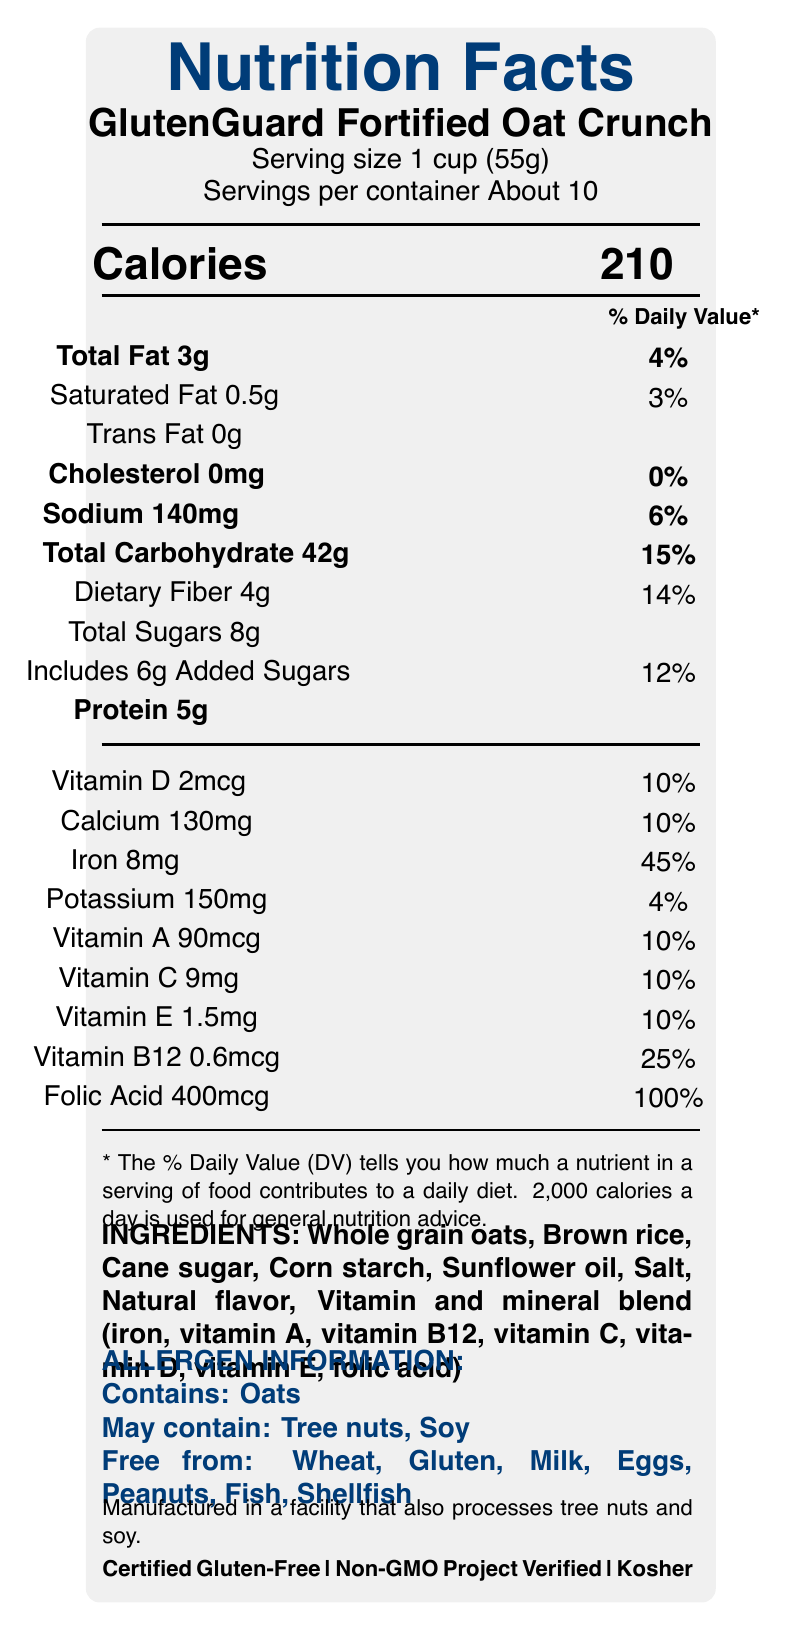what is the serving size for GlutenGuard Fortified Oat Crunch? The serving size is explicitly stated in the Nutrition Facts label as "Serving size 1 cup (55g)".
Answer: 1 cup (55g) how many servings are in each container? The label mentions "Servings per container About 10".
Answer: About 10 how much iron is in one serving? The Nutrition Facts label states that there is 8mg of iron per serving.
Answer: 8mg what percentage of the daily value of dietary fiber does one serving provide? The document indicates that one serving provides 14% of the daily value for dietary fiber.
Answer: 14% list the vitamins that are fortified in this cereal. The ingredients list these vitamins and minerals as part of a "Vitamin and mineral blend".
Answer: Vitamin A, Vitamin B12, Vitamin C, Vitamin D, Vitamin E, folic acid which allergens does this product contain? A. Tree nuts B. Soy C. Oats D. Milk The label states that the cereal contains "Oats".
Answer: C. Oats how many grams of total sugars are in one serving? The Nutrition Facts label shows that there are 8 grams of total sugars per serving.
Answer: 8g what is the total carbohydrate content per serving? A. 14g B. 30g C. 42g D. 50g The document indicates a total carbohydrate content of 42 grams per serving.
Answer: C. 42g is this cereal gluten-free? The label states that the cereal is "Certified Gluten-Free".
Answer: Yes what is the main idea of this Nutrition Facts label? The document provides detailed information about a gluten-free cereal, including its serving size, nutritional content per serving, vitamins and minerals, ingredients, potential allergens, and certifications.
Answer: The label describes the nutritional content, ingredients, allergens, and certifications of GlutenGuard Fortified Oat Crunch, a gluten-free cereal. what kind of packaging does this product have? There is no visible information in the document about the type of packaging used for this product.
Answer: Cannot be determined which vitamin is present in the highest percentage of daily value? The label shows folic acid as having a daily value of 100%.
Answer: Folic acid how much sodium is in one serving? The label indicates that there are 140mg of sodium per serving.
Answer: 140mg name two certifications that this cereal has. The certification section lists "Certified Gluten-Free" and "Non-GMO Project Verified" among others.
Answer: Certified Gluten-Free, Non-GMO Project Verified is the font size used for the product name larger than the font size used for the serving size? The product name is displayed using a larger font size than the serving size.
Answer: Yes how is allergen control managed in the manufacturing process? The label mentions "strict allergen control protocols in place to minimize cross-contamination risks".
Answer: The label states that strict allergen control protocols are in place to minimize cross-contamination risks. what is the caloric value of one serving? A. 100 calories B. 150 calories C. 200 calories D. 210 calories The document lists the caloric value for one serving as 210 calories.
Answer: D. 210 calories 